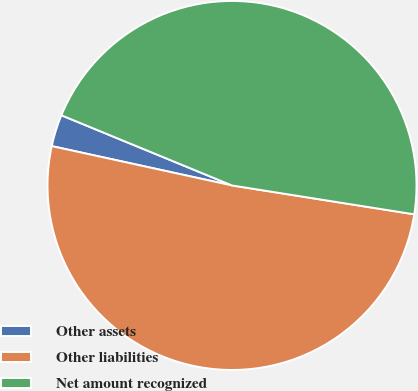Convert chart. <chart><loc_0><loc_0><loc_500><loc_500><pie_chart><fcel>Other assets<fcel>Other liabilities<fcel>Net amount recognized<nl><fcel>2.79%<fcel>50.92%<fcel>46.29%<nl></chart> 